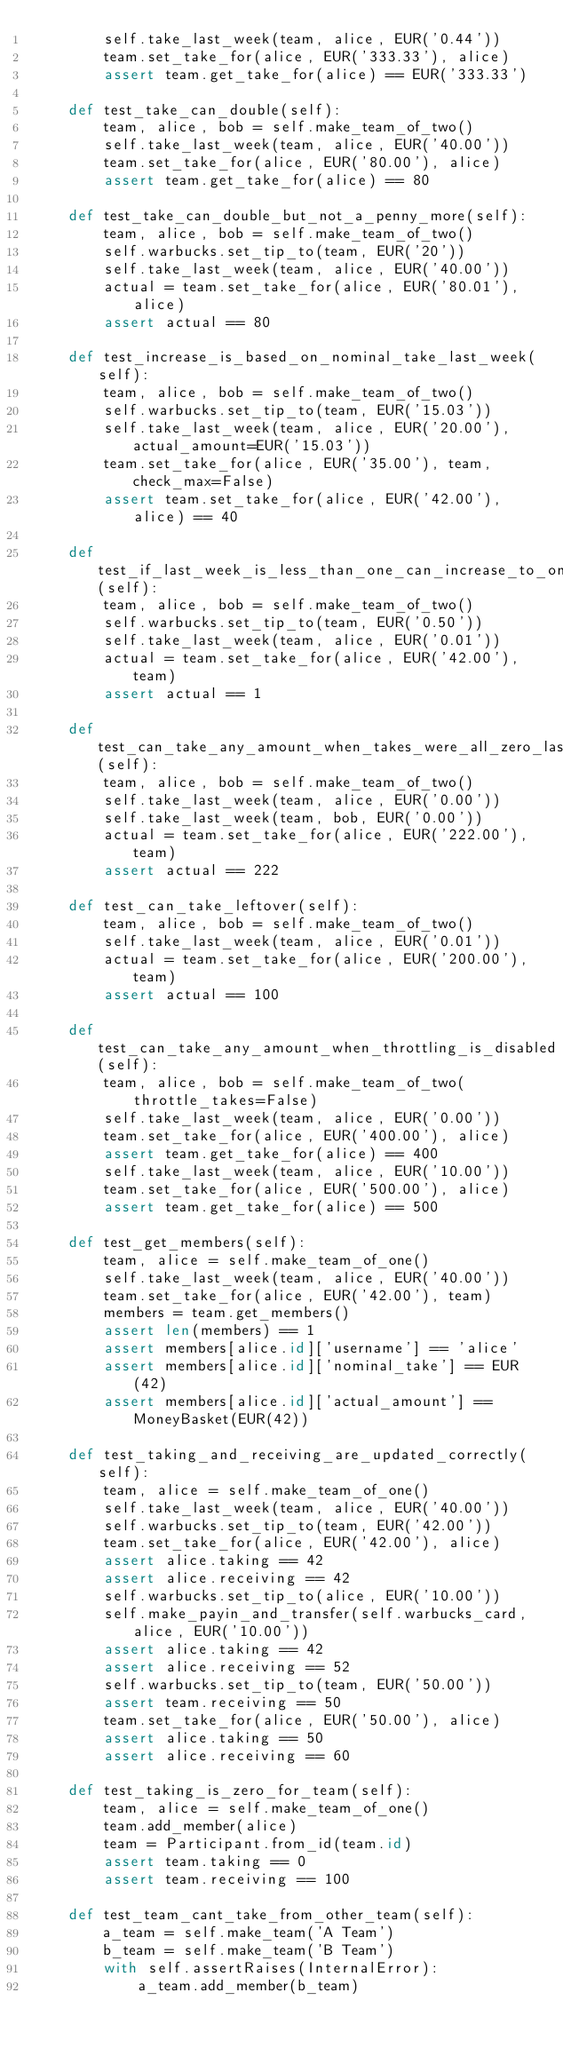Convert code to text. <code><loc_0><loc_0><loc_500><loc_500><_Python_>        self.take_last_week(team, alice, EUR('0.44'))
        team.set_take_for(alice, EUR('333.33'), alice)
        assert team.get_take_for(alice) == EUR('333.33')

    def test_take_can_double(self):
        team, alice, bob = self.make_team_of_two()
        self.take_last_week(team, alice, EUR('40.00'))
        team.set_take_for(alice, EUR('80.00'), alice)
        assert team.get_take_for(alice) == 80

    def test_take_can_double_but_not_a_penny_more(self):
        team, alice, bob = self.make_team_of_two()
        self.warbucks.set_tip_to(team, EUR('20'))
        self.take_last_week(team, alice, EUR('40.00'))
        actual = team.set_take_for(alice, EUR('80.01'), alice)
        assert actual == 80

    def test_increase_is_based_on_nominal_take_last_week(self):
        team, alice, bob = self.make_team_of_two()
        self.warbucks.set_tip_to(team, EUR('15.03'))
        self.take_last_week(team, alice, EUR('20.00'), actual_amount=EUR('15.03'))
        team.set_take_for(alice, EUR('35.00'), team, check_max=False)
        assert team.set_take_for(alice, EUR('42.00'), alice) == 40

    def test_if_last_week_is_less_than_one_can_increase_to_one(self):
        team, alice, bob = self.make_team_of_two()
        self.warbucks.set_tip_to(team, EUR('0.50'))
        self.take_last_week(team, alice, EUR('0.01'))
        actual = team.set_take_for(alice, EUR('42.00'), team)
        assert actual == 1

    def test_can_take_any_amount_when_takes_were_all_zero_last_week(self):
        team, alice, bob = self.make_team_of_two()
        self.take_last_week(team, alice, EUR('0.00'))
        self.take_last_week(team, bob, EUR('0.00'))
        actual = team.set_take_for(alice, EUR('222.00'), team)
        assert actual == 222

    def test_can_take_leftover(self):
        team, alice, bob = self.make_team_of_two()
        self.take_last_week(team, alice, EUR('0.01'))
        actual = team.set_take_for(alice, EUR('200.00'), team)
        assert actual == 100

    def test_can_take_any_amount_when_throttling_is_disabled(self):
        team, alice, bob = self.make_team_of_two(throttle_takes=False)
        self.take_last_week(team, alice, EUR('0.00'))
        team.set_take_for(alice, EUR('400.00'), alice)
        assert team.get_take_for(alice) == 400
        self.take_last_week(team, alice, EUR('10.00'))
        team.set_take_for(alice, EUR('500.00'), alice)
        assert team.get_take_for(alice) == 500

    def test_get_members(self):
        team, alice = self.make_team_of_one()
        self.take_last_week(team, alice, EUR('40.00'))
        team.set_take_for(alice, EUR('42.00'), team)
        members = team.get_members()
        assert len(members) == 1
        assert members[alice.id]['username'] == 'alice'
        assert members[alice.id]['nominal_take'] == EUR(42)
        assert members[alice.id]['actual_amount'] == MoneyBasket(EUR(42))

    def test_taking_and_receiving_are_updated_correctly(self):
        team, alice = self.make_team_of_one()
        self.take_last_week(team, alice, EUR('40.00'))
        self.warbucks.set_tip_to(team, EUR('42.00'))
        team.set_take_for(alice, EUR('42.00'), alice)
        assert alice.taking == 42
        assert alice.receiving == 42
        self.warbucks.set_tip_to(alice, EUR('10.00'))
        self.make_payin_and_transfer(self.warbucks_card, alice, EUR('10.00'))
        assert alice.taking == 42
        assert alice.receiving == 52
        self.warbucks.set_tip_to(team, EUR('50.00'))
        assert team.receiving == 50
        team.set_take_for(alice, EUR('50.00'), alice)
        assert alice.taking == 50
        assert alice.receiving == 60

    def test_taking_is_zero_for_team(self):
        team, alice = self.make_team_of_one()
        team.add_member(alice)
        team = Participant.from_id(team.id)
        assert team.taking == 0
        assert team.receiving == 100

    def test_team_cant_take_from_other_team(self):
        a_team = self.make_team('A Team')
        b_team = self.make_team('B Team')
        with self.assertRaises(InternalError):
            a_team.add_member(b_team)
</code> 